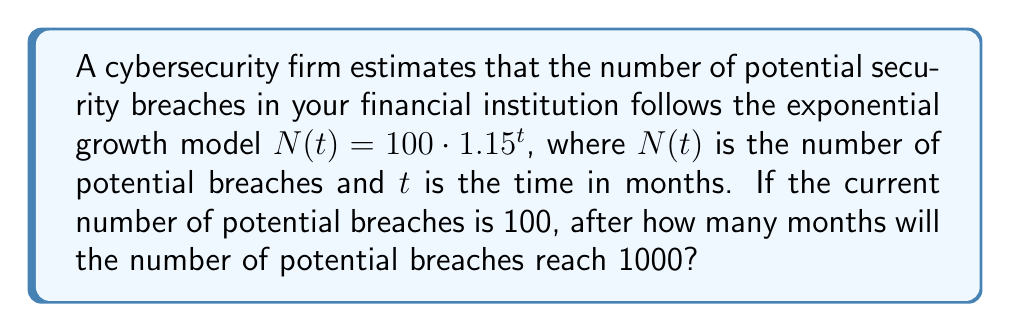Provide a solution to this math problem. To solve this problem, we need to use the exponential growth formula and logarithms. Let's approach this step-by-step:

1) We start with the given exponential growth model:
   $N(t) = 100 \cdot 1.15^t$

2) We want to find $t$ when $N(t) = 1000$. So, let's set up the equation:
   $1000 = 100 \cdot 1.15^t$

3) Divide both sides by 100:
   $10 = 1.15^t$

4) Now, we need to solve for $t$. We can do this by taking the logarithm of both sides. Let's use the natural logarithm (ln):
   $\ln(10) = \ln(1.15^t)$

5) Using the logarithm property $\ln(a^b) = b\ln(a)$, we get:
   $\ln(10) = t \cdot \ln(1.15)$

6) Now we can solve for $t$:
   $t = \frac{\ln(10)}{\ln(1.15)}$

7) Using a calculator:
   $t \approx 16.27$ months

8) Since we're dealing with whole months, we need to round up to the next integer:
   $t = 17$ months

Therefore, it will take 17 months for the number of potential breaches to reach 1000.
Answer: 17 months 